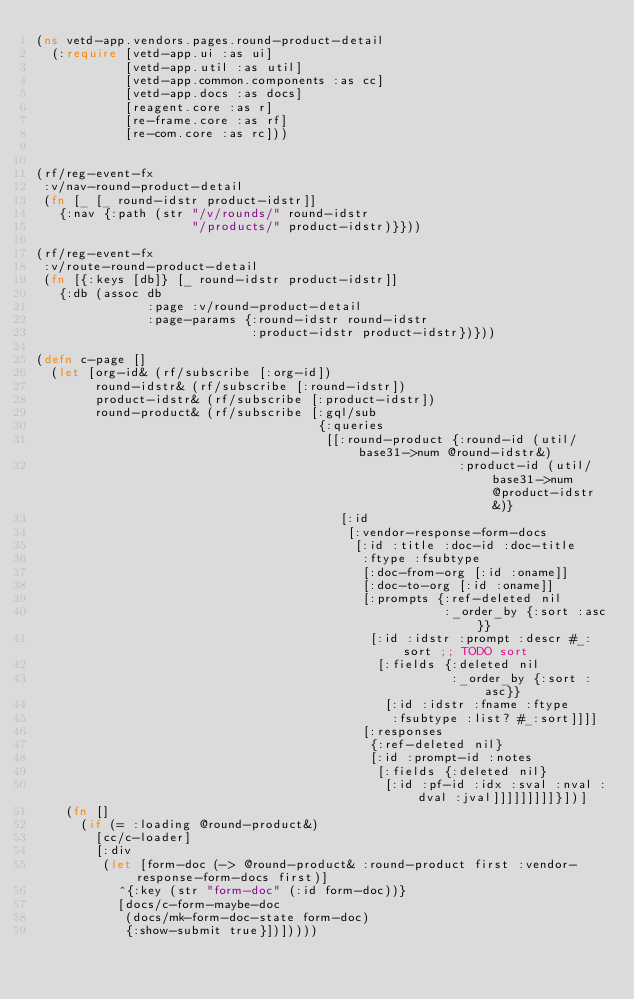Convert code to text. <code><loc_0><loc_0><loc_500><loc_500><_Clojure_>(ns vetd-app.vendors.pages.round-product-detail
  (:require [vetd-app.ui :as ui]
            [vetd-app.util :as util]
            [vetd-app.common.components :as cc]
            [vetd-app.docs :as docs]
            [reagent.core :as r]
            [re-frame.core :as rf]
            [re-com.core :as rc]))


(rf/reg-event-fx
 :v/nav-round-product-detail
 (fn [_ [_ round-idstr product-idstr]]
   {:nav {:path (str "/v/rounds/" round-idstr
                     "/products/" product-idstr)}}))

(rf/reg-event-fx
 :v/route-round-product-detail
 (fn [{:keys [db]} [_ round-idstr product-idstr]]
   {:db (assoc db
               :page :v/round-product-detail
               :page-params {:round-idstr round-idstr
                             :product-idstr product-idstr})}))

(defn c-page []
  (let [org-id& (rf/subscribe [:org-id])
        round-idstr& (rf/subscribe [:round-idstr])
        product-idstr& (rf/subscribe [:product-idstr])
        round-product& (rf/subscribe [:gql/sub
                                      {:queries
                                       [[:round-product {:round-id (util/base31->num @round-idstr&)
                                                         :product-id (util/base31->num @product-idstr&)}
                                         [:id
                                          [:vendor-response-form-docs
                                           [:id :title :doc-id :doc-title
                                            :ftype :fsubtype
                                            [:doc-from-org [:id :oname]]
                                            [:doc-to-org [:id :oname]]
                                            [:prompts {:ref-deleted nil
                                                       :_order_by {:sort :asc}}
                                             [:id :idstr :prompt :descr #_:sort ;; TODO sort
                                              [:fields {:deleted nil
                                                        :_order_by {:sort :asc}}
                                               [:id :idstr :fname :ftype
                                                :fsubtype :list? #_:sort]]]]
                                            [:responses
                                             {:ref-deleted nil}
                                             [:id :prompt-id :notes
                                              [:fields {:deleted nil}
                                               [:id :pf-id :idx :sval :nval :dval :jval]]]]]]]]]}])]
    (fn []
      (if (= :loading @round-product&)
        [cc/c-loader]
        [:div
         (let [form-doc (-> @round-product& :round-product first :vendor-response-form-docs first)]
           ^{:key (str "form-doc" (:id form-doc))}
           [docs/c-form-maybe-doc
            (docs/mk-form-doc-state form-doc)
            {:show-submit true}])]))))
</code> 